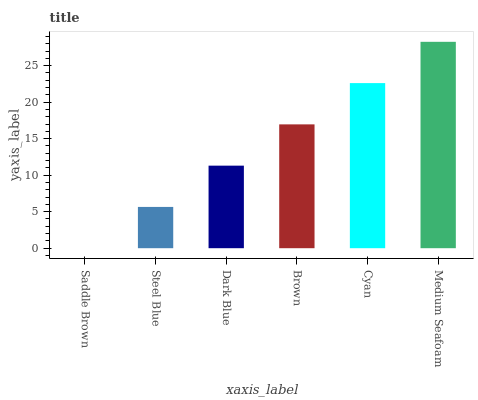Is Saddle Brown the minimum?
Answer yes or no. Yes. Is Medium Seafoam the maximum?
Answer yes or no. Yes. Is Steel Blue the minimum?
Answer yes or no. No. Is Steel Blue the maximum?
Answer yes or no. No. Is Steel Blue greater than Saddle Brown?
Answer yes or no. Yes. Is Saddle Brown less than Steel Blue?
Answer yes or no. Yes. Is Saddle Brown greater than Steel Blue?
Answer yes or no. No. Is Steel Blue less than Saddle Brown?
Answer yes or no. No. Is Brown the high median?
Answer yes or no. Yes. Is Dark Blue the low median?
Answer yes or no. Yes. Is Saddle Brown the high median?
Answer yes or no. No. Is Cyan the low median?
Answer yes or no. No. 